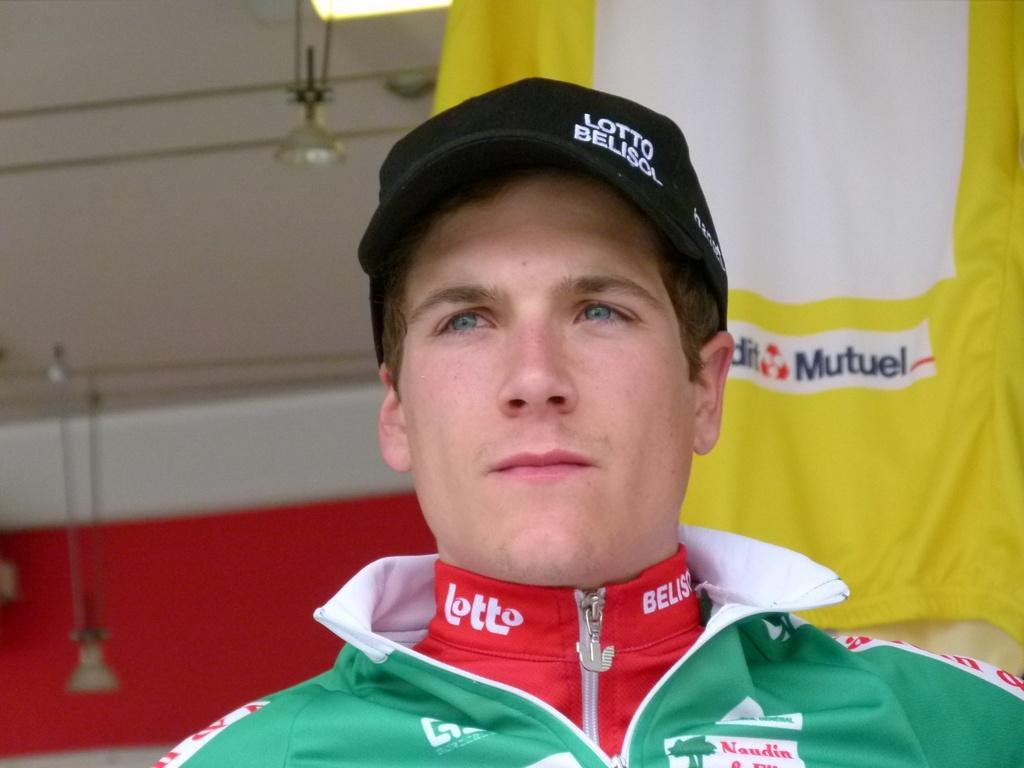Describe this image in one or two sentences. In this picture I can see a man is wearing a cap on his head and looks like a cloth hanging in the back and I can see few lights on the ceiling. 